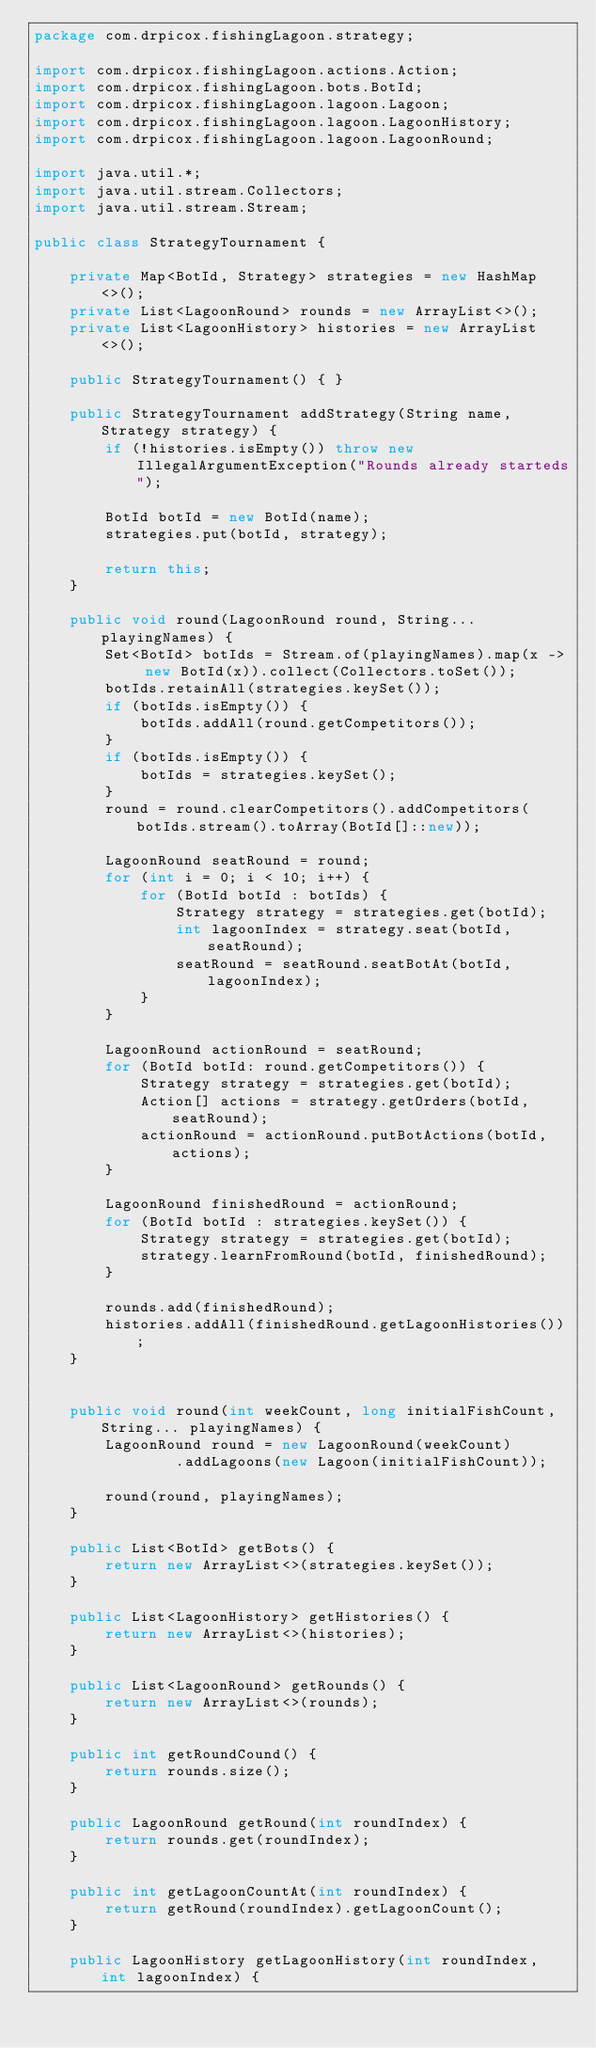<code> <loc_0><loc_0><loc_500><loc_500><_Java_>package com.drpicox.fishingLagoon.strategy;

import com.drpicox.fishingLagoon.actions.Action;
import com.drpicox.fishingLagoon.bots.BotId;
import com.drpicox.fishingLagoon.lagoon.Lagoon;
import com.drpicox.fishingLagoon.lagoon.LagoonHistory;
import com.drpicox.fishingLagoon.lagoon.LagoonRound;

import java.util.*;
import java.util.stream.Collectors;
import java.util.stream.Stream;

public class StrategyTournament {

    private Map<BotId, Strategy> strategies = new HashMap<>();
    private List<LagoonRound> rounds = new ArrayList<>();
    private List<LagoonHistory> histories = new ArrayList<>();

    public StrategyTournament() { }

    public StrategyTournament addStrategy(String name, Strategy strategy) {
        if (!histories.isEmpty()) throw new IllegalArgumentException("Rounds already starteds");

        BotId botId = new BotId(name);
        strategies.put(botId, strategy);

        return this;
    }

    public void round(LagoonRound round, String... playingNames) {
        Set<BotId> botIds = Stream.of(playingNames).map(x -> new BotId(x)).collect(Collectors.toSet());
        botIds.retainAll(strategies.keySet());
        if (botIds.isEmpty()) {
            botIds.addAll(round.getCompetitors());
        }
        if (botIds.isEmpty()) {
            botIds = strategies.keySet();
        }
        round = round.clearCompetitors().addCompetitors(botIds.stream().toArray(BotId[]::new));

        LagoonRound seatRound = round;
        for (int i = 0; i < 10; i++) {
            for (BotId botId : botIds) {
                Strategy strategy = strategies.get(botId);
                int lagoonIndex = strategy.seat(botId, seatRound);
                seatRound = seatRound.seatBotAt(botId, lagoonIndex);
            }
        }

        LagoonRound actionRound = seatRound;
        for (BotId botId: round.getCompetitors()) {
            Strategy strategy = strategies.get(botId);
            Action[] actions = strategy.getOrders(botId, seatRound);
            actionRound = actionRound.putBotActions(botId, actions);
        }

        LagoonRound finishedRound = actionRound;
        for (BotId botId : strategies.keySet()) {
            Strategy strategy = strategies.get(botId);
            strategy.learnFromRound(botId, finishedRound);
        }

        rounds.add(finishedRound);
        histories.addAll(finishedRound.getLagoonHistories());
    }


    public void round(int weekCount, long initialFishCount, String... playingNames) {
        LagoonRound round = new LagoonRound(weekCount)
                .addLagoons(new Lagoon(initialFishCount));

        round(round, playingNames);
    }

    public List<BotId> getBots() {
        return new ArrayList<>(strategies.keySet());
    }

    public List<LagoonHistory> getHistories() {
        return new ArrayList<>(histories);
    }

    public List<LagoonRound> getRounds() {
        return new ArrayList<>(rounds);
    }

    public int getRoundCound() {
        return rounds.size();
    }

    public LagoonRound getRound(int roundIndex) {
        return rounds.get(roundIndex);
    }

    public int getLagoonCountAt(int roundIndex) {
        return getRound(roundIndex).getLagoonCount();
    }

    public LagoonHistory getLagoonHistory(int roundIndex, int lagoonIndex) {</code> 